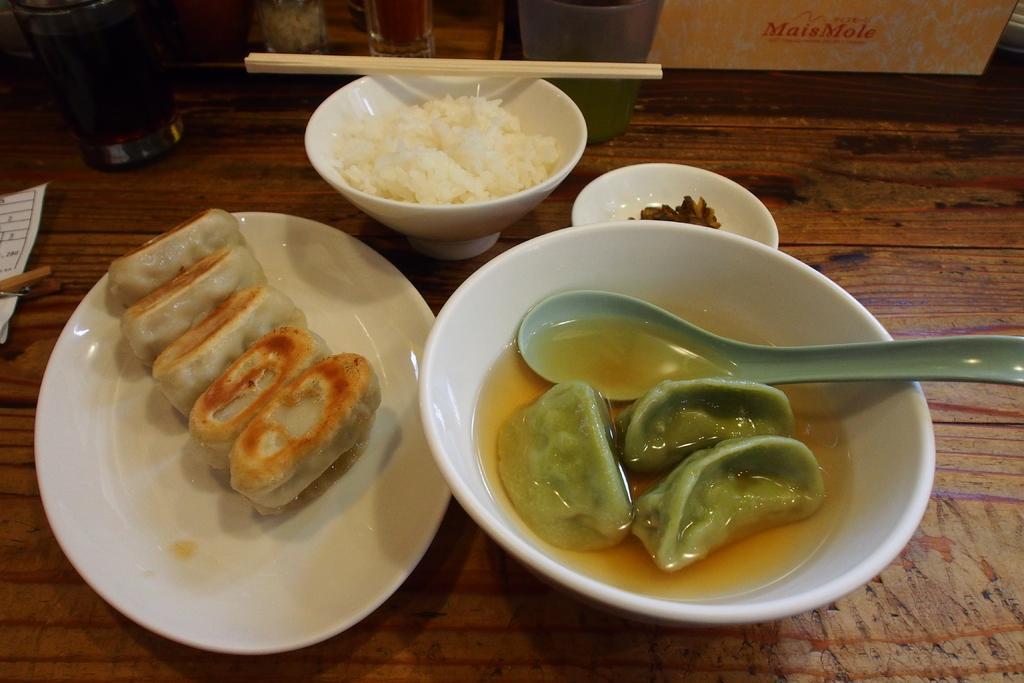Can you describe this image briefly? As we can see in the image there is a table. On table there is glass, box, plates, bowls, spoon, chopsticks, paper and different types of food items. 